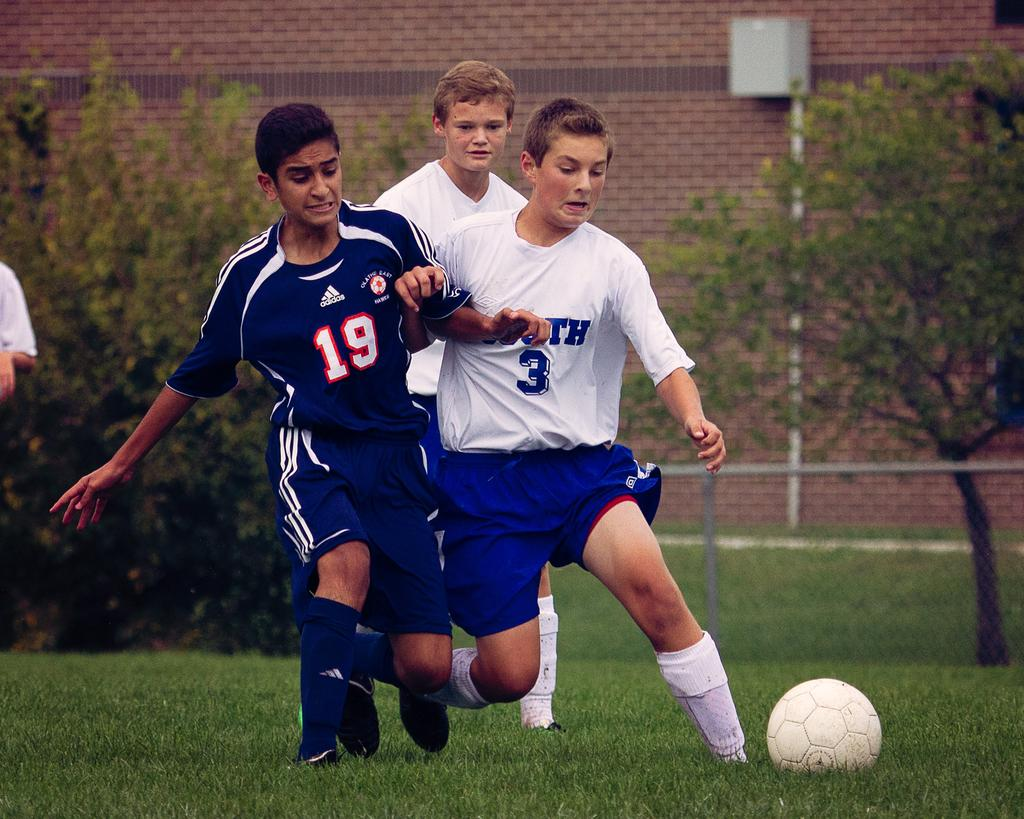Provide a one-sentence caption for the provided image. Players 19 and 3 fight for the soccer ball on the playing field. 